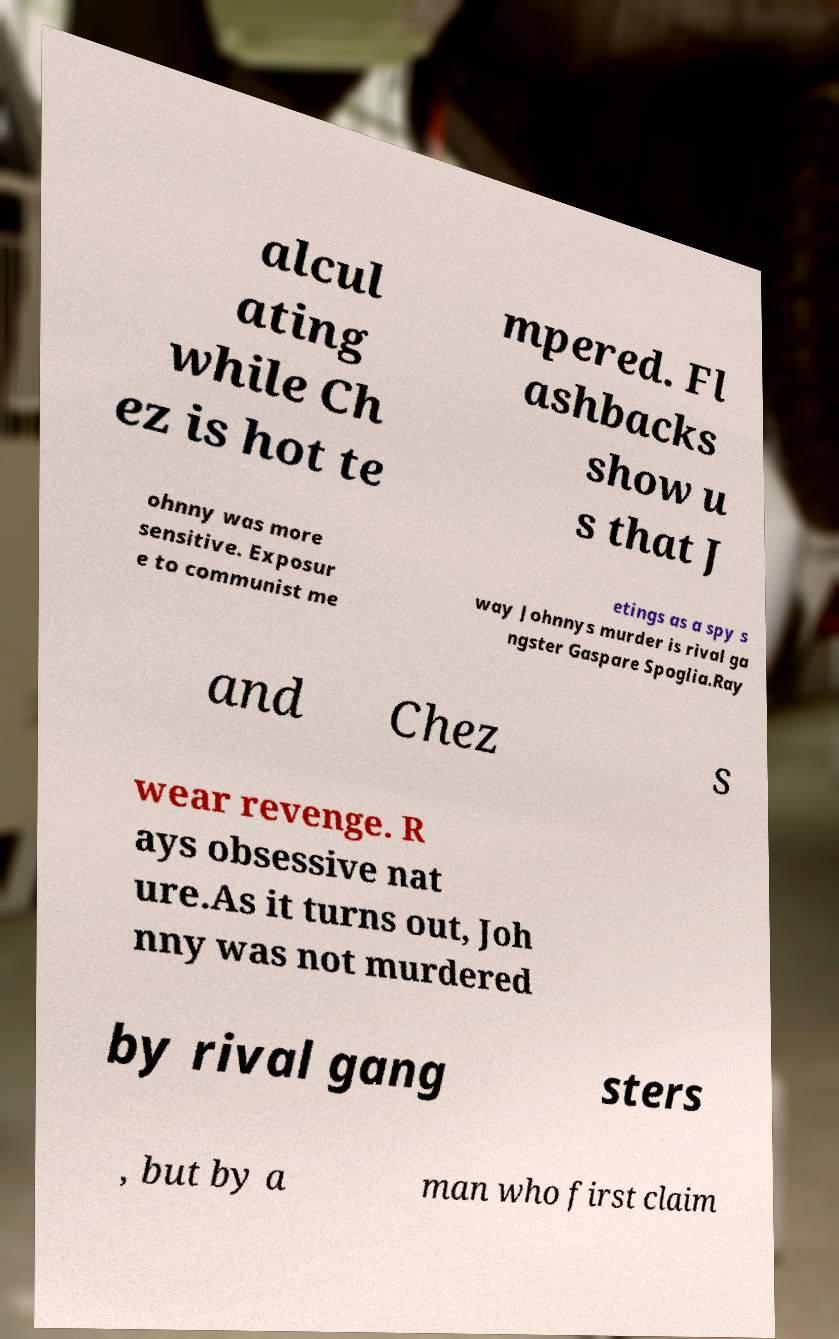For documentation purposes, I need the text within this image transcribed. Could you provide that? alcul ating while Ch ez is hot te mpered. Fl ashbacks show u s that J ohnny was more sensitive. Exposur e to communist me etings as a spy s way Johnnys murder is rival ga ngster Gaspare Spoglia.Ray and Chez s wear revenge. R ays obsessive nat ure.As it turns out, Joh nny was not murdered by rival gang sters , but by a man who first claim 